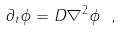Convert formula to latex. <formula><loc_0><loc_0><loc_500><loc_500>\partial _ { t } \phi = D \nabla ^ { 2 } \phi \ ,</formula> 